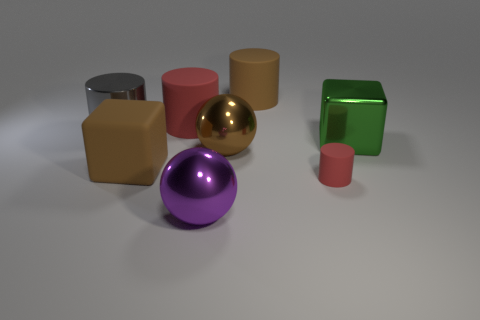What shape is the purple object that is the same size as the gray metal thing?
Your answer should be compact. Sphere. Is there a ball of the same color as the tiny matte cylinder?
Provide a short and direct response. No. Are there an equal number of tiny rubber objects behind the large brown metal object and brown cylinders that are behind the brown rubber cylinder?
Provide a succinct answer. Yes. There is a gray metal thing; is it the same shape as the red rubber thing that is behind the tiny matte cylinder?
Provide a short and direct response. Yes. How many other things are there of the same material as the large gray object?
Offer a very short reply. 3. There is a small red rubber thing; are there any large gray cylinders in front of it?
Your answer should be very brief. No. Does the metallic block have the same size as the brown object behind the brown ball?
Provide a succinct answer. Yes. What color is the metallic sphere behind the cube to the left of the big red cylinder?
Offer a terse response. Brown. Is the size of the gray thing the same as the green block?
Ensure brevity in your answer.  Yes. What color is the big matte thing that is left of the brown sphere and behind the green object?
Your response must be concise. Red. 